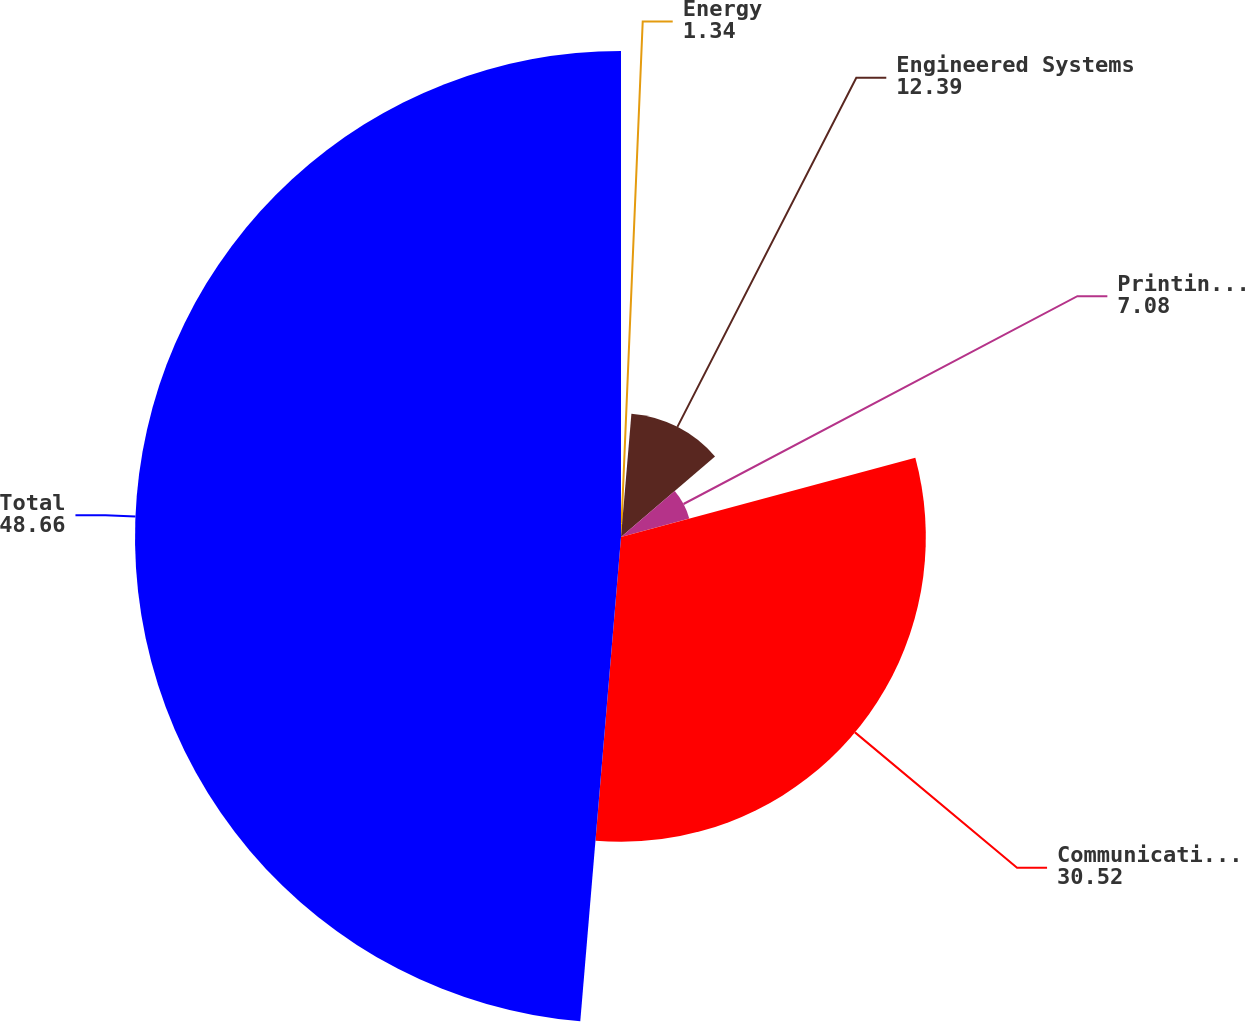Convert chart to OTSL. <chart><loc_0><loc_0><loc_500><loc_500><pie_chart><fcel>Energy<fcel>Engineered Systems<fcel>Printing & Identification<fcel>Communication Technologies<fcel>Total<nl><fcel>1.34%<fcel>12.39%<fcel>7.08%<fcel>30.52%<fcel>48.66%<nl></chart> 